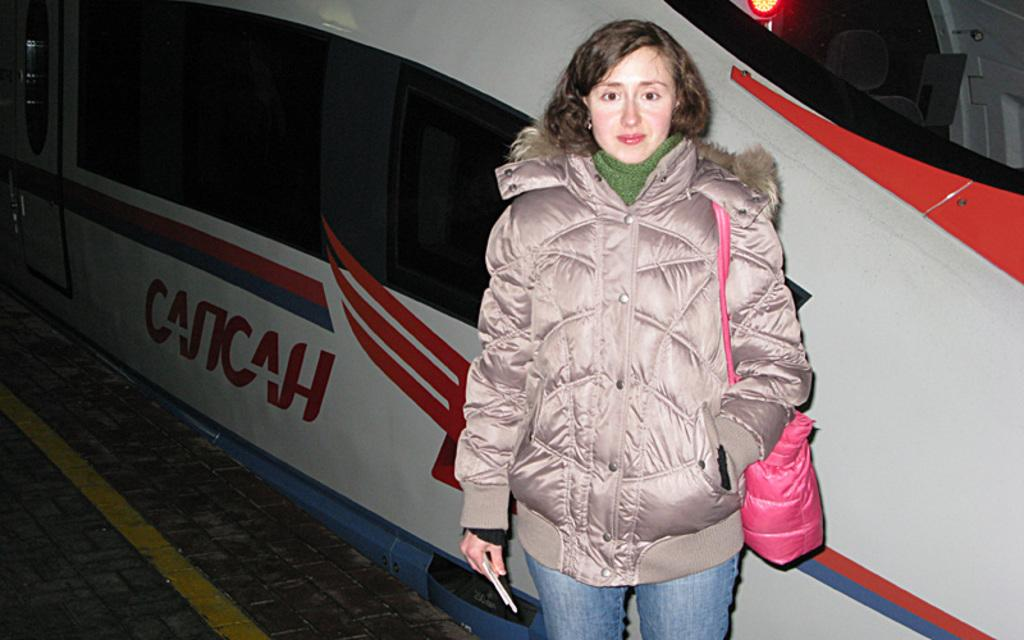Who is the main subject in the image? There is a woman in the image. What type of clothing is the woman wearing? The woman is wearing a jacket and jeans pants. What color is the woman's bag? The woman has a pink bag. Can you describe any text or writing in the image? There is an object with writing in the background of the image. What is the woman's opinion on string theory in the image? There is no indication in the image of the woman's opinion on string theory, as the image focuses on her clothing and accessories. 